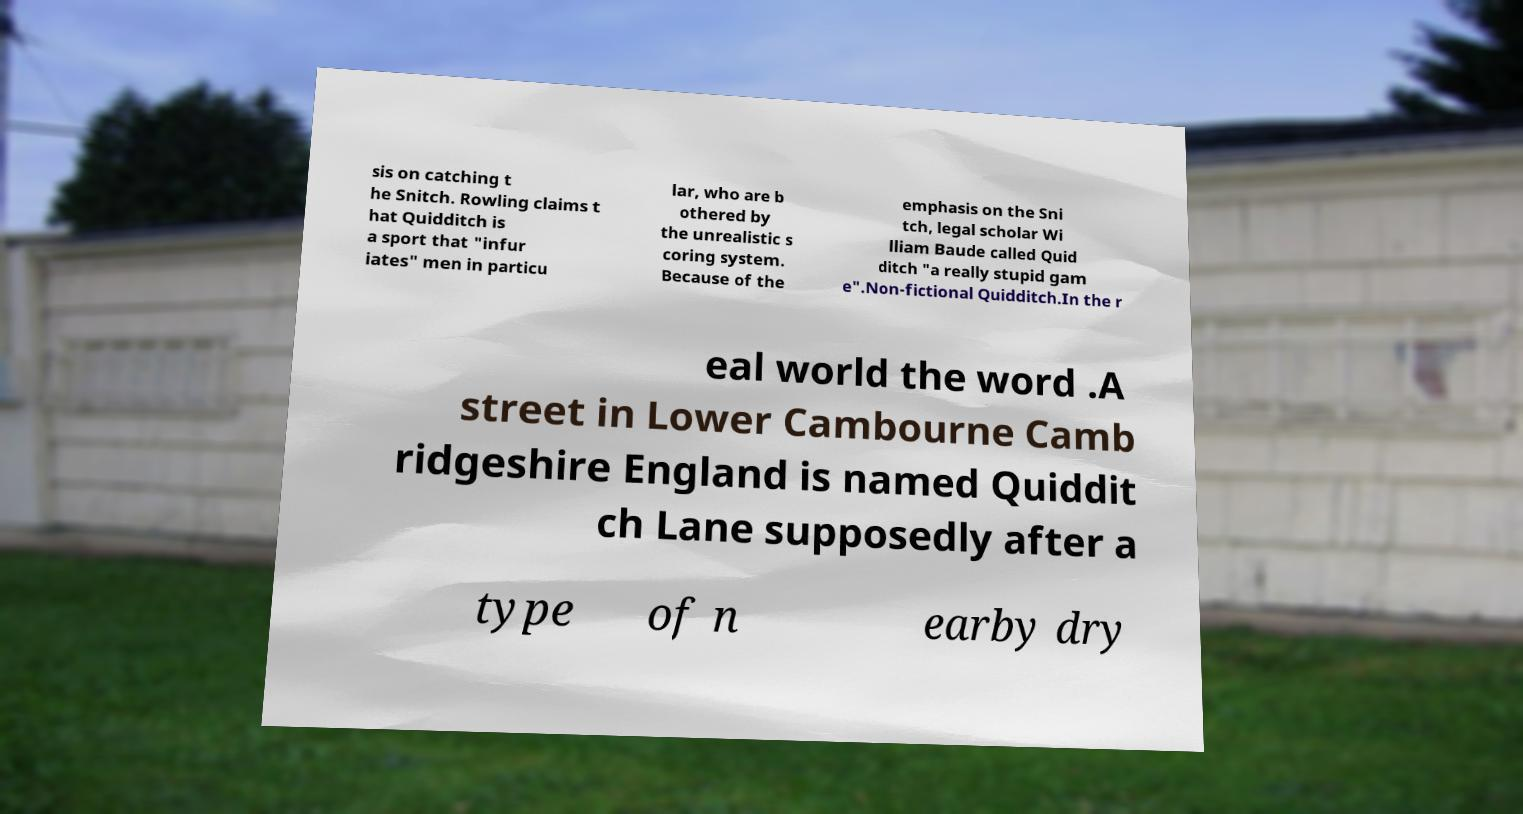Could you assist in decoding the text presented in this image and type it out clearly? sis on catching t he Snitch. Rowling claims t hat Quidditch is a sport that "infur iates" men in particu lar, who are b othered by the unrealistic s coring system. Because of the emphasis on the Sni tch, legal scholar Wi lliam Baude called Quid ditch "a really stupid gam e".Non-fictional Quidditch.In the r eal world the word .A street in Lower Cambourne Camb ridgeshire England is named Quiddit ch Lane supposedly after a type of n earby dry 